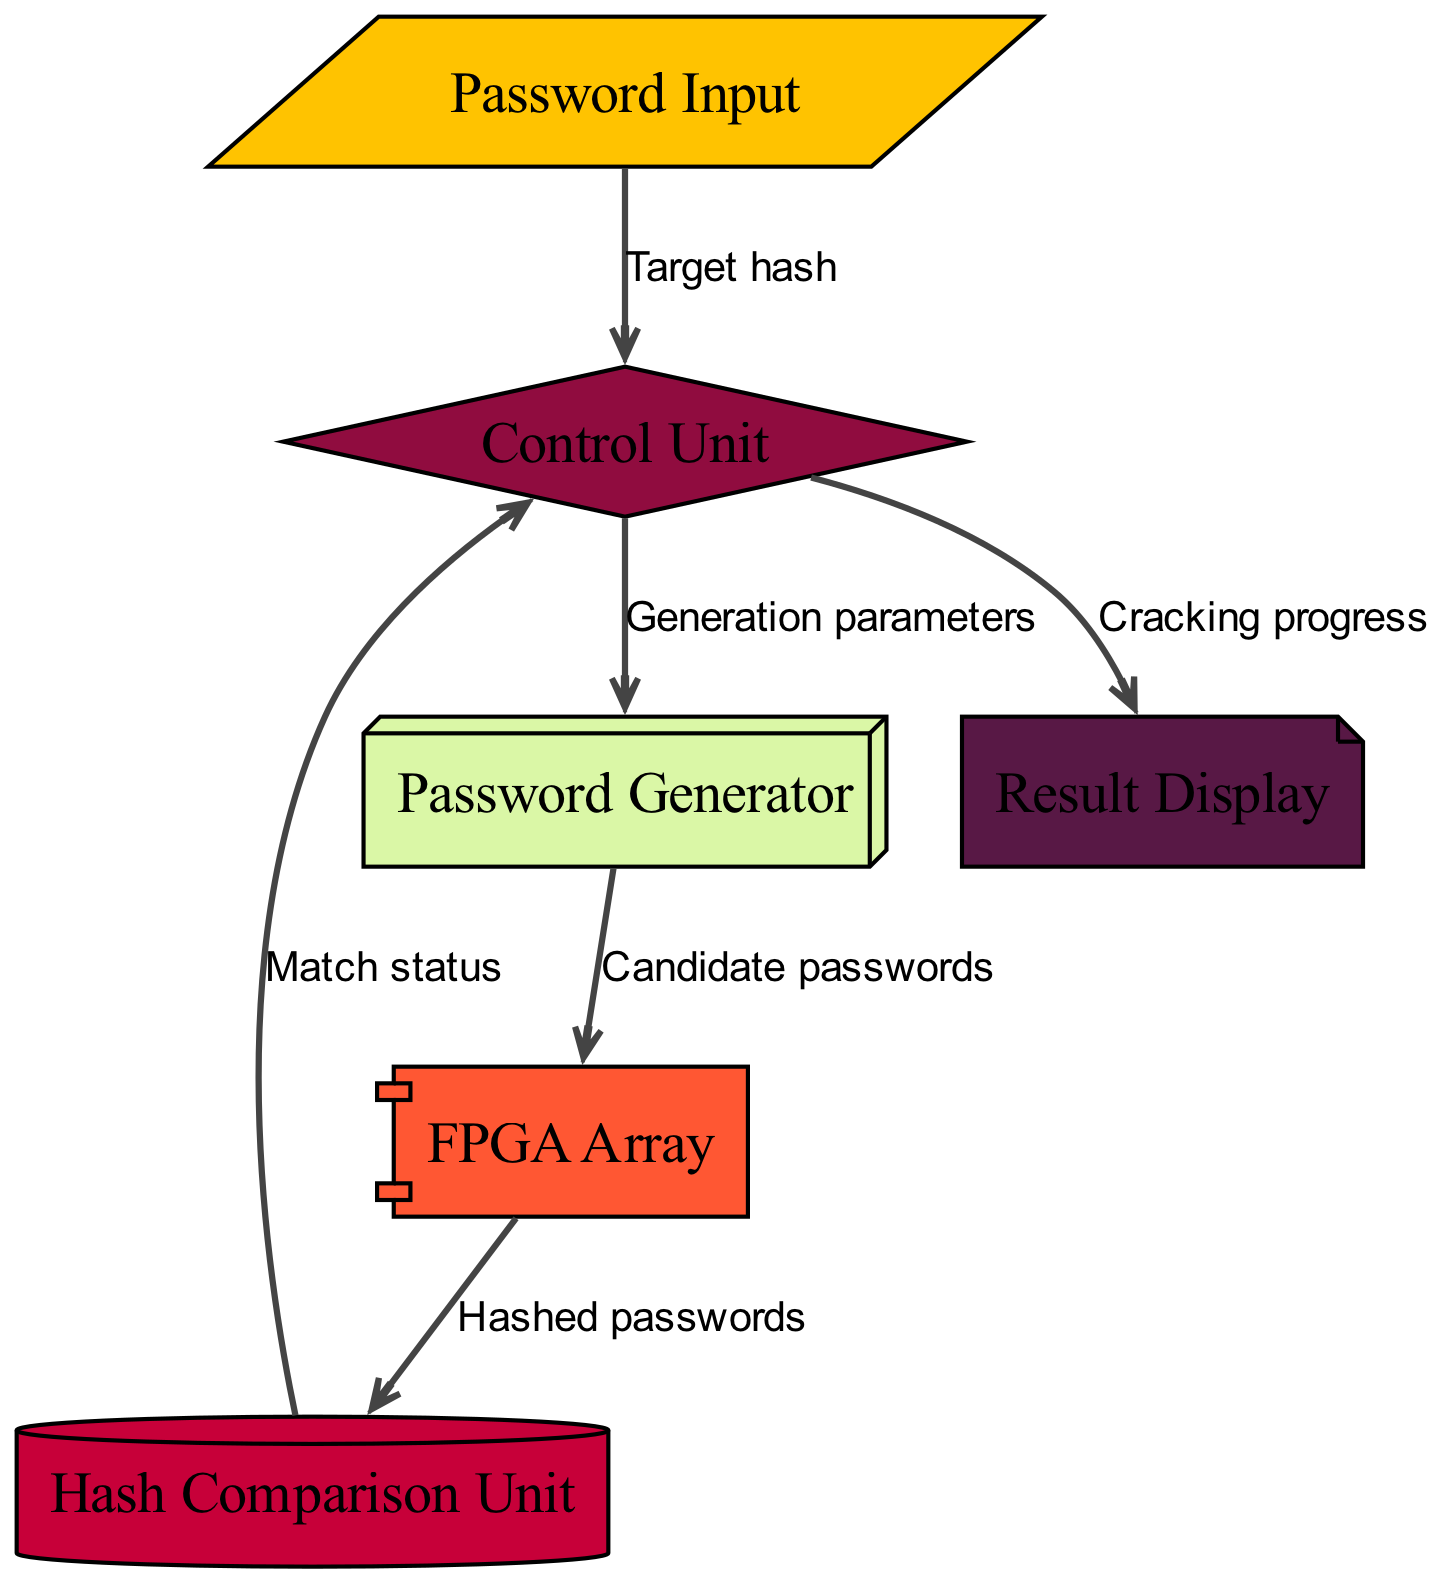What is the first unit a password goes through? The diagram shows that the first unit for inputting the password is the "Password Input" node. It is the starting point where the target hash is introduced into the system.
Answer: Password Input How many nodes are present in the diagram? By counting the nodes listed in the data, there are six nodes: Password Input, Password Generator, FPGA Array, Hash Comparison Unit, Control Unit, and Result Display.
Answer: Six Which unit receives the hashed passwords? The diagram indicates that the "Hash Comparison Unit" receives the hashed passwords from the "FPGA Array." This is the next step in the flow, as shown by the directed edge.
Answer: Hash Comparison Unit What is the function of the Control Unit? The diagram illustrates that the "Control Unit" plays a crucial role in managing processes by receiving input from the "Password Input" and sending out "Generation parameters" to the "Password Generator" and "Cracking progress" to the "Result Display." It controls the flow of information.
Answer: Manage processes From which unit does the Result Display receive information? The "Result Display" receives information from the "Control Unit," which sends updates on the cracking progress as indicated by the directed edge shown in the diagram.
Answer: Control Unit What is sent from the FPGA Array to the Hash Comparison Unit? The diagram specifies that "Hashed passwords" are sent from the "FPGA Array" to the "Hash Comparison Unit" as part of the password cracking process.
Answer: Hashed passwords What does the Password Generator produce? According to the diagram, the "Password Generator" produces "Candidate passwords," which are sent to the "FPGA Array" for processing in the brute-force attack method.
Answer: Candidate passwords What determines the target hash in the Control Unit? In the diagram, the "Password Input" node provides the "Target hash" to the "Control Unit," which is essential for initiating the password cracking process.
Answer: Target hash How does the Control Unit interact with the Password Generator? The diagram shows that the "Control Unit" sends "Generation parameters" to the "Password Generator," which helps it to create potential passwords for cracking. This two-way communication supports the flow of the brute-force method.
Answer: Generation parameters 